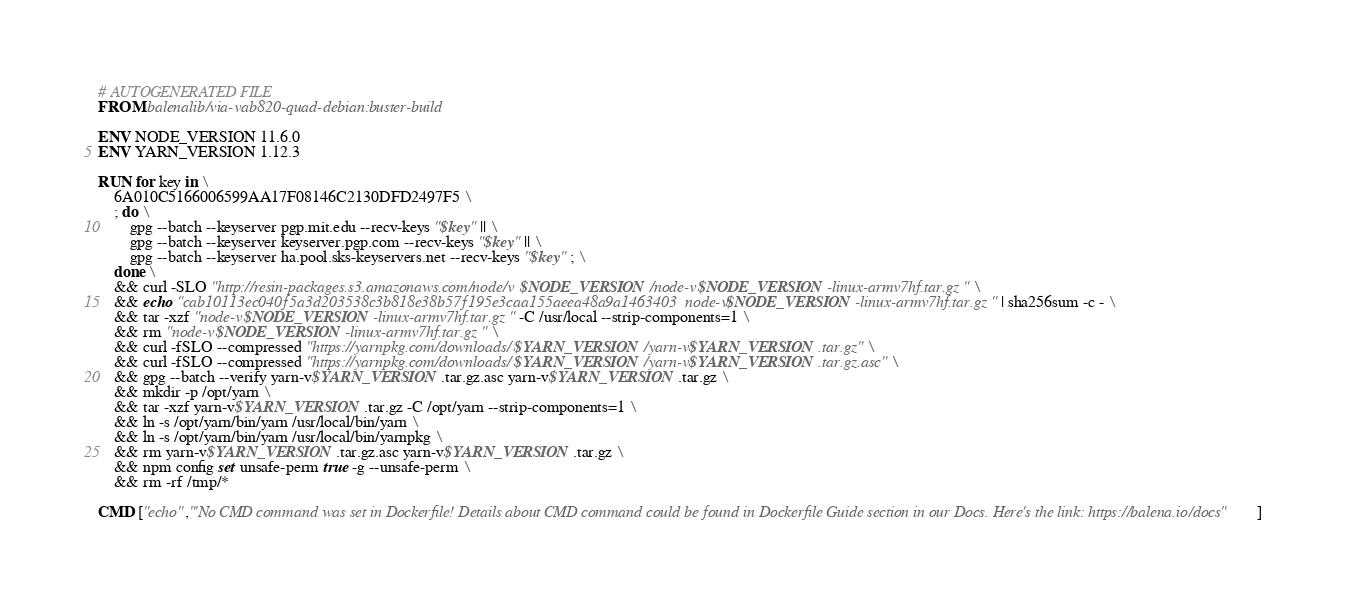<code> <loc_0><loc_0><loc_500><loc_500><_Dockerfile_># AUTOGENERATED FILE
FROM balenalib/via-vab820-quad-debian:buster-build

ENV NODE_VERSION 11.6.0
ENV YARN_VERSION 1.12.3

RUN for key in \
	6A010C5166006599AA17F08146C2130DFD2497F5 \
	; do \
		gpg --batch --keyserver pgp.mit.edu --recv-keys "$key" || \
		gpg --batch --keyserver keyserver.pgp.com --recv-keys "$key" || \
		gpg --batch --keyserver ha.pool.sks-keyservers.net --recv-keys "$key" ; \
	done \
	&& curl -SLO "http://resin-packages.s3.amazonaws.com/node/v$NODE_VERSION/node-v$NODE_VERSION-linux-armv7hf.tar.gz" \
	&& echo "cab10113ec040f5a3d203538c3b818e38b57f195e3caa155aeea48a9a1463403  node-v$NODE_VERSION-linux-armv7hf.tar.gz" | sha256sum -c - \
	&& tar -xzf "node-v$NODE_VERSION-linux-armv7hf.tar.gz" -C /usr/local --strip-components=1 \
	&& rm "node-v$NODE_VERSION-linux-armv7hf.tar.gz" \
	&& curl -fSLO --compressed "https://yarnpkg.com/downloads/$YARN_VERSION/yarn-v$YARN_VERSION.tar.gz" \
	&& curl -fSLO --compressed "https://yarnpkg.com/downloads/$YARN_VERSION/yarn-v$YARN_VERSION.tar.gz.asc" \
	&& gpg --batch --verify yarn-v$YARN_VERSION.tar.gz.asc yarn-v$YARN_VERSION.tar.gz \
	&& mkdir -p /opt/yarn \
	&& tar -xzf yarn-v$YARN_VERSION.tar.gz -C /opt/yarn --strip-components=1 \
	&& ln -s /opt/yarn/bin/yarn /usr/local/bin/yarn \
	&& ln -s /opt/yarn/bin/yarn /usr/local/bin/yarnpkg \
	&& rm yarn-v$YARN_VERSION.tar.gz.asc yarn-v$YARN_VERSION.tar.gz \
	&& npm config set unsafe-perm true -g --unsafe-perm \
	&& rm -rf /tmp/*

CMD ["echo","'No CMD command was set in Dockerfile! Details about CMD command could be found in Dockerfile Guide section in our Docs. Here's the link: https://balena.io/docs"]</code> 